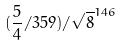Convert formula to latex. <formula><loc_0><loc_0><loc_500><loc_500>( \frac { 5 } { 4 } / 3 5 9 ) / \sqrt { 8 } ^ { 1 4 6 }</formula> 